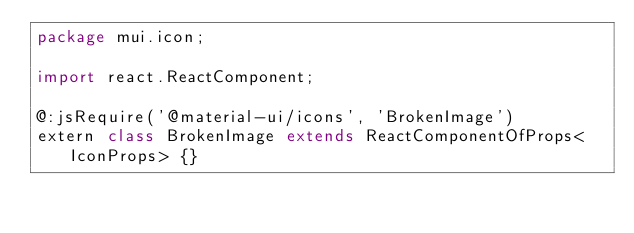Convert code to text. <code><loc_0><loc_0><loc_500><loc_500><_Haxe_>package mui.icon;

import react.ReactComponent;

@:jsRequire('@material-ui/icons', 'BrokenImage')
extern class BrokenImage extends ReactComponentOfProps<IconProps> {}
</code> 